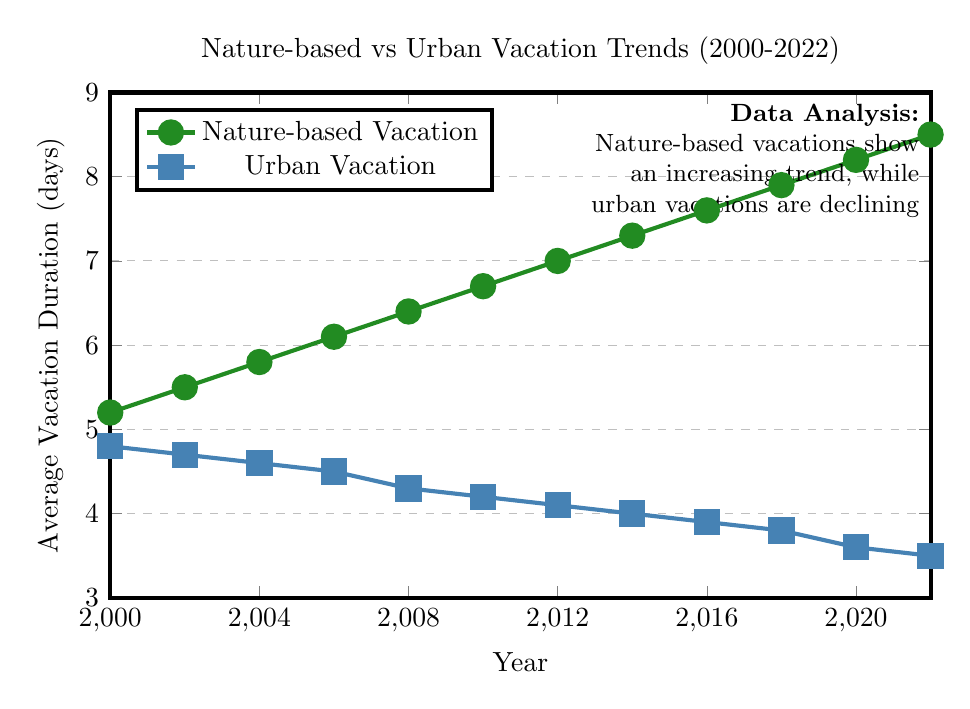What is the average vacation duration for nature-based trips in 2006? Look at the point corresponding to the year 2006 on the green line representing nature-based vacation duration. The y-axis value at this point is 6.1 days.
Answer: 6.1 days Over the entire period from 2000 to 2022, did the duration of nature-based vacations increase or decrease? Observe the trend of the green line over the specified period. It starts at 5.2 days in 2000 and ends at 8.5 days in 2022, showing an upward trend.
Answer: Increased Which type of vacation had a longer duration in 2018? Compare the y-axis values for the year 2018 for both green (nature-based) and blue (urban) lines. Nature-based is at 7.9 days and urban is at 3.8 days.
Answer: Nature-based vacation What is the difference in average vacation duration between nature-based trips and urban trips in 2010? Check the values for 2010: nature-based vacation is 6.7 days and urban vacation is 4.2 days. The difference is 6.7 - 4.2 = 2.5 days.
Answer: 2.5 days By how many days did urban vacation durations change from 2004 to 2020? Look at the values for urban vacations in 2004 (4.6 days) and 2020 (3.6 days). The change is 4.6 - 3.6 = 1 day.
Answer: 1 day Was there any year where both vacation types had the same duration? Scan both lines to see if they intersect. In this graph, the lines never intersect, so there is no such year.
Answer: No What was the average duration of a nature-based vacation over the entire period? Sum the nature-based values and divide by the number of years: (5.2 + 5.5 + 5.8 + 6.1 + 6.4 + 6.7 + 7.0 + 7.3 + 7.6 + 7.9 + 8.2 + 8.5) / 12 = 6.76667 days.
Answer: 6.77 days What is the rate of increase in the average duration of nature-based vacations per year from 2000 to 2022? Calculate the total increase: 8.5 - 5.2 = 3.3 days. Divide this by the number of years (2022 - 2000 = 22 years): 3.3 / 22 = 0.15 days per year.
Answer: 0.15 days per year In which year did urban vacations see the sharpest decline? Analyze the blue line to identify the year with the steepest slope downward. The sharpest decline appears between 2006 (4.5 days) and 2008 (4.3 days).
Answer: 2006 to 2008 What is the cumulative decrease in urban vacation duration from 2000 to 2022? Subtract the 2022 value from the 2000 value: 4.8 - 3.5 = 1.3 days.
Answer: 1.3 days 